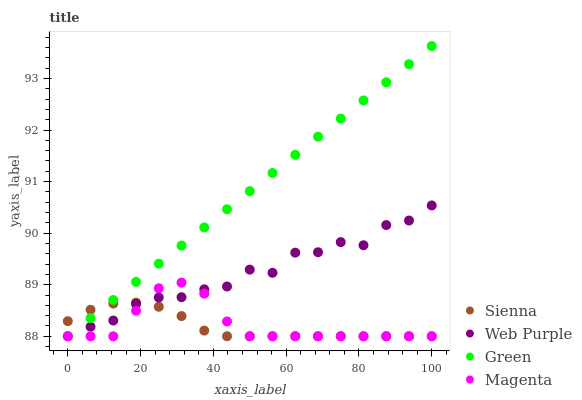Does Sienna have the minimum area under the curve?
Answer yes or no. Yes. Does Green have the maximum area under the curve?
Answer yes or no. Yes. Does Web Purple have the minimum area under the curve?
Answer yes or no. No. Does Web Purple have the maximum area under the curve?
Answer yes or no. No. Is Green the smoothest?
Answer yes or no. Yes. Is Web Purple the roughest?
Answer yes or no. Yes. Is Web Purple the smoothest?
Answer yes or no. No. Is Green the roughest?
Answer yes or no. No. Does Sienna have the lowest value?
Answer yes or no. Yes. Does Green have the highest value?
Answer yes or no. Yes. Does Web Purple have the highest value?
Answer yes or no. No. Does Web Purple intersect Magenta?
Answer yes or no. Yes. Is Web Purple less than Magenta?
Answer yes or no. No. Is Web Purple greater than Magenta?
Answer yes or no. No. 